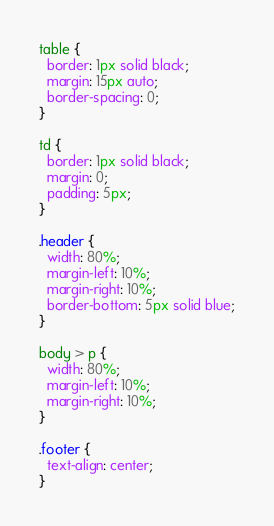<code> <loc_0><loc_0><loc_500><loc_500><_CSS_>table {
  border: 1px solid black;
  margin: 15px auto;
  border-spacing: 0;
}

td {
  border: 1px solid black;
  margin: 0;
  padding: 5px;
}

.header {
  width: 80%;
  margin-left: 10%;
  margin-right: 10%;
  border-bottom: 5px solid blue;
}

body > p {
  width: 80%;
  margin-left: 10%;
  margin-right: 10%;
}

.footer {
  text-align: center;
}</code> 